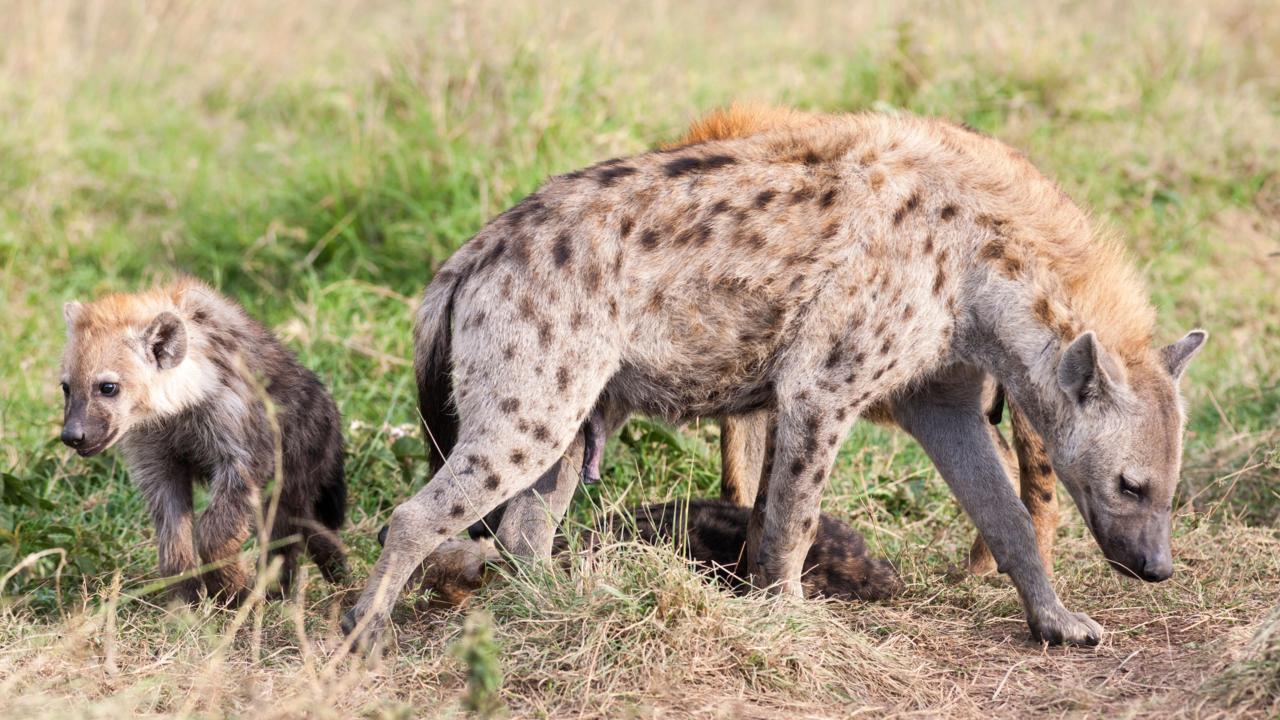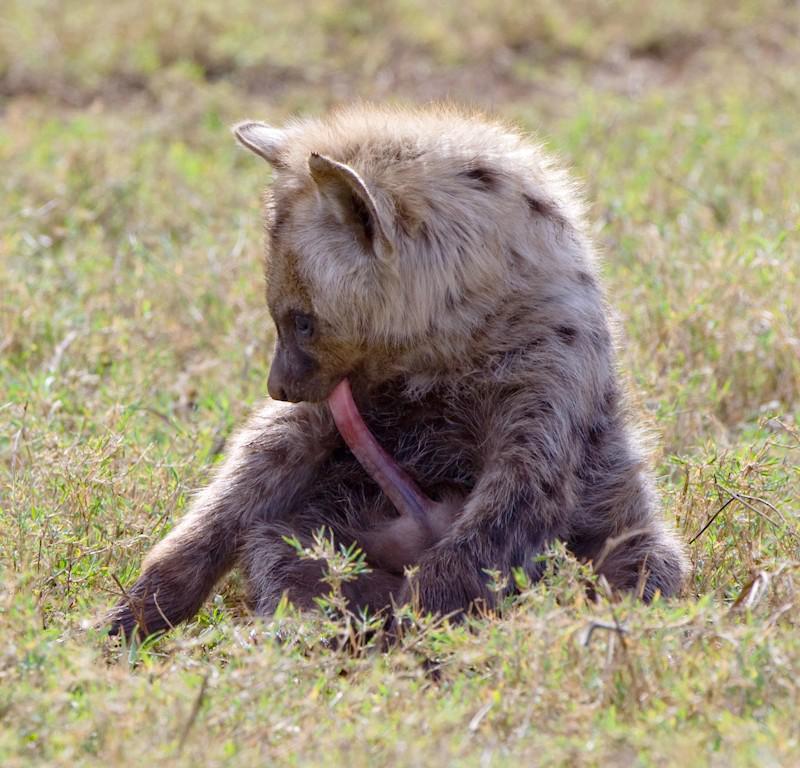The first image is the image on the left, the second image is the image on the right. For the images displayed, is the sentence "One image contains at least four hyenas." factually correct? Answer yes or no. No. The first image is the image on the left, the second image is the image on the right. Assess this claim about the two images: "There are at least three spotted hyenas gathered together in the right image.". Correct or not? Answer yes or no. No. 